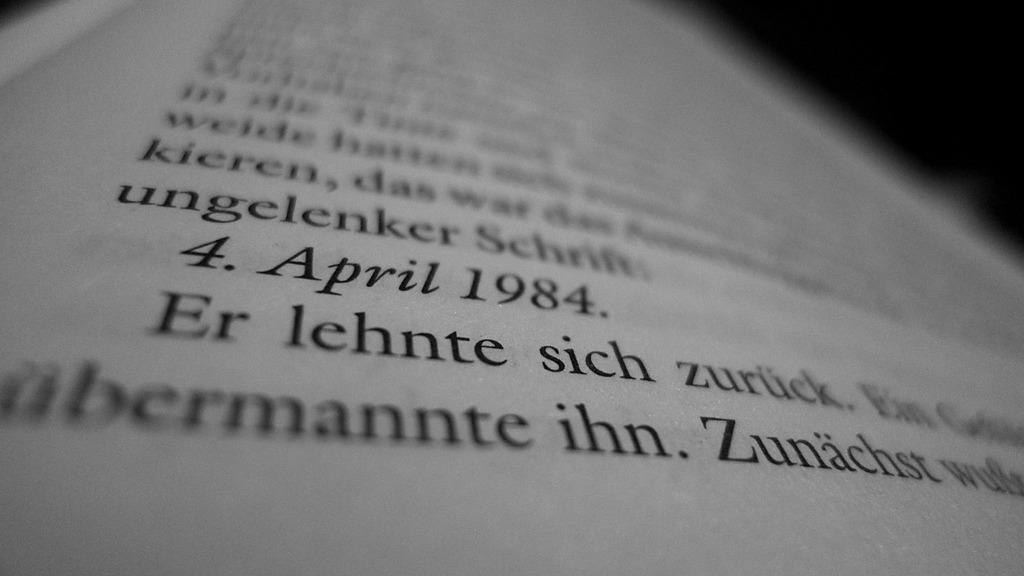Provide a one-sentence caption for the provided image. A page from a book displaying some words in German. 